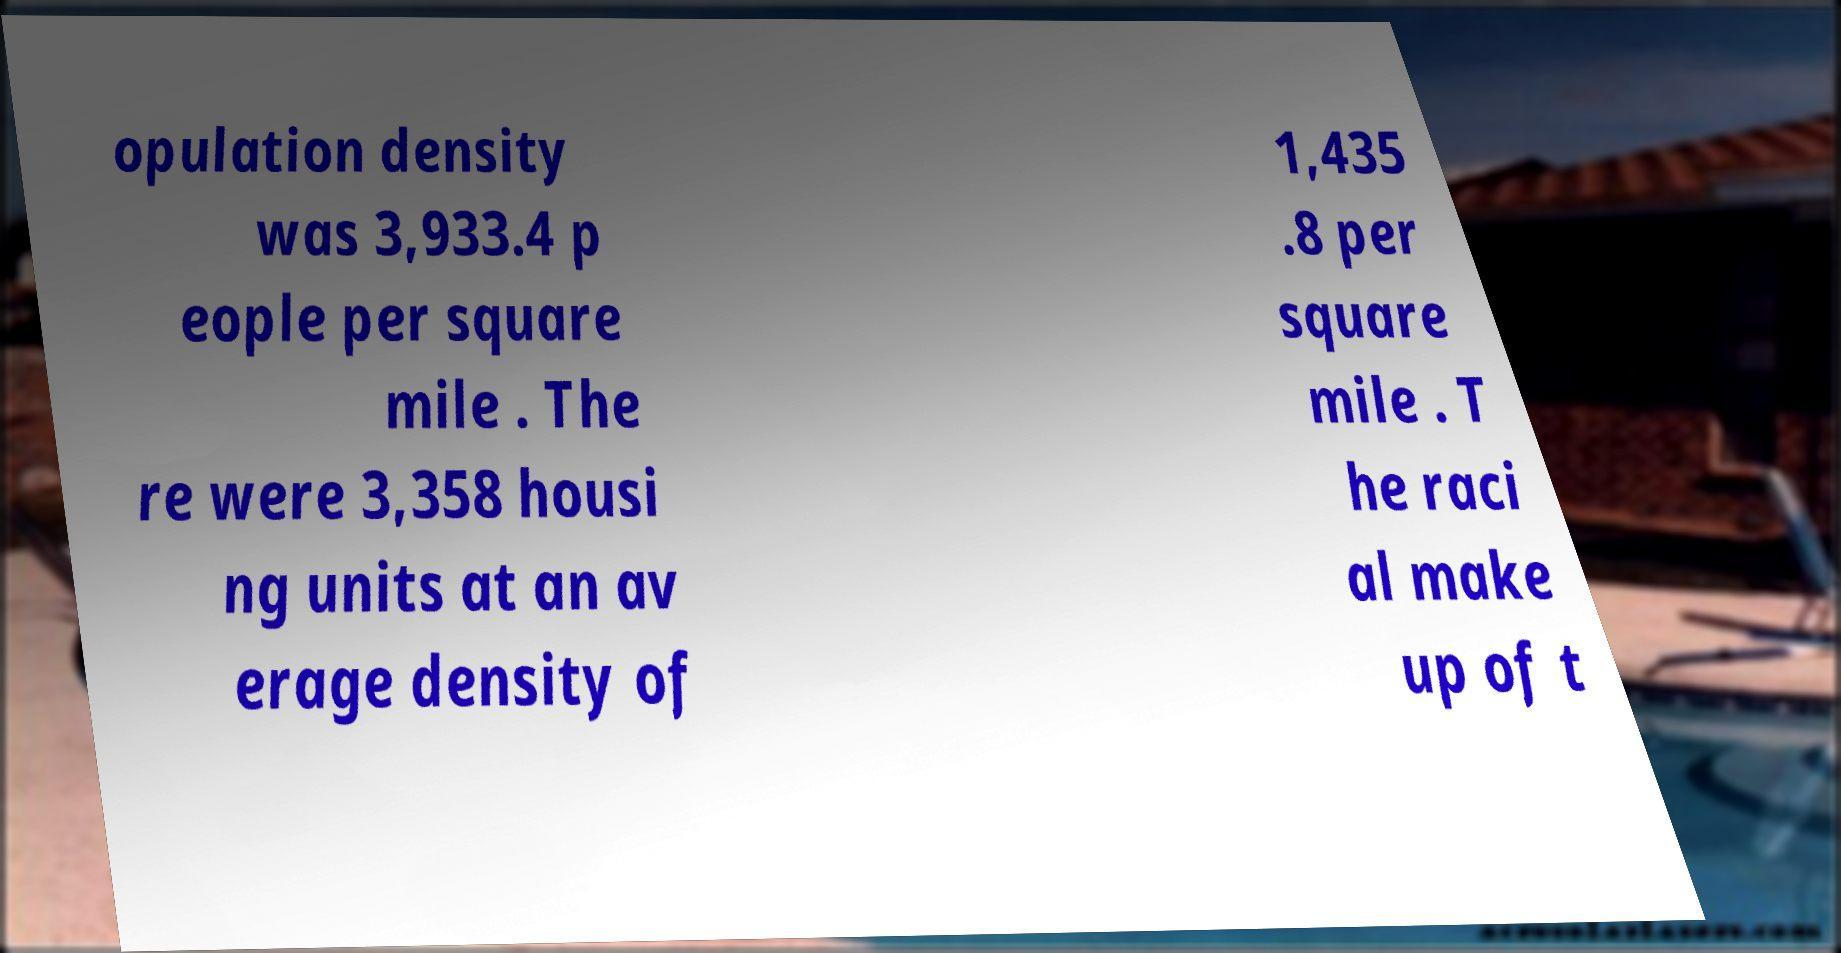Could you assist in decoding the text presented in this image and type it out clearly? opulation density was 3,933.4 p eople per square mile . The re were 3,358 housi ng units at an av erage density of 1,435 .8 per square mile . T he raci al make up of t 